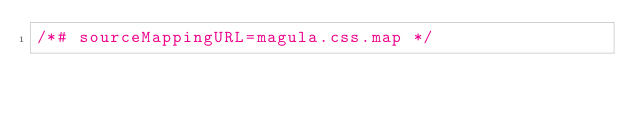Convert code to text. <code><loc_0><loc_0><loc_500><loc_500><_CSS_>/*# sourceMappingURL=magula.css.map */</code> 